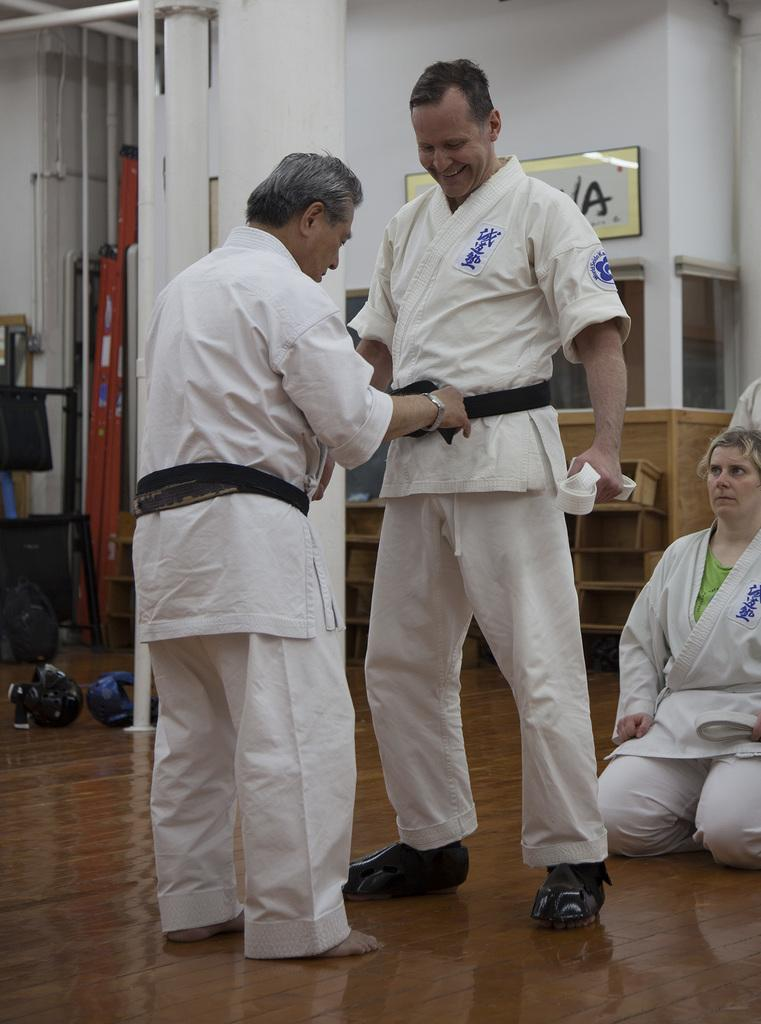Provide a one-sentence caption for the provided image. older man tightening belt of another judo participant that has a world seido patch on his sleeve. 